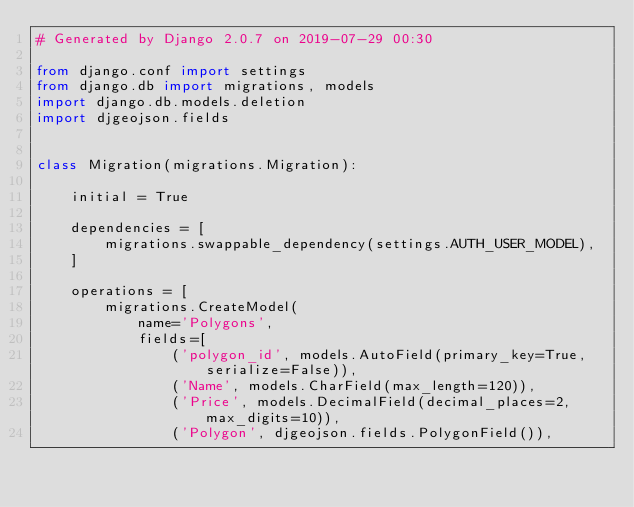<code> <loc_0><loc_0><loc_500><loc_500><_Python_># Generated by Django 2.0.7 on 2019-07-29 00:30

from django.conf import settings
from django.db import migrations, models
import django.db.models.deletion
import djgeojson.fields


class Migration(migrations.Migration):

    initial = True

    dependencies = [
        migrations.swappable_dependency(settings.AUTH_USER_MODEL),
    ]

    operations = [
        migrations.CreateModel(
            name='Polygons',
            fields=[
                ('polygon_id', models.AutoField(primary_key=True, serialize=False)),
                ('Name', models.CharField(max_length=120)),
                ('Price', models.DecimalField(decimal_places=2, max_digits=10)),
                ('Polygon', djgeojson.fields.PolygonField()),</code> 